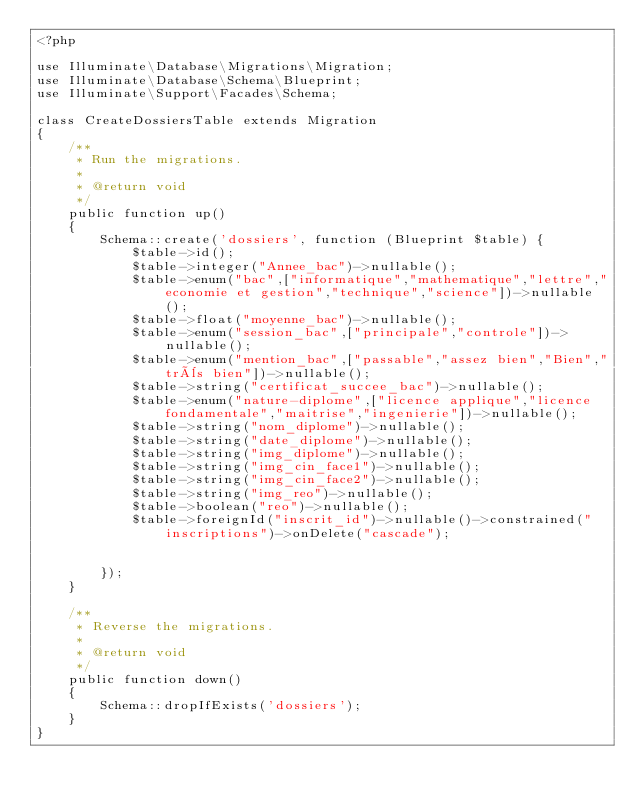<code> <loc_0><loc_0><loc_500><loc_500><_PHP_><?php

use Illuminate\Database\Migrations\Migration;
use Illuminate\Database\Schema\Blueprint;
use Illuminate\Support\Facades\Schema;

class CreateDossiersTable extends Migration
{
    /**
     * Run the migrations.
     *
     * @return void
     */
    public function up()
    {
        Schema::create('dossiers', function (Blueprint $table) {
            $table->id();
            $table->integer("Annee_bac")->nullable();
            $table->enum("bac",["informatique","mathematique","lettre","economie et gestion","technique","science"])->nullable();
            $table->float("moyenne_bac")->nullable();
            $table->enum("session_bac",["principale","controle"])->nullable();
            $table->enum("mention_bac",["passable","assez bien","Bien","très bien"])->nullable();
            $table->string("certificat_succee_bac")->nullable();
            $table->enum("nature-diplome",["licence applique","licence fondamentale","maitrise","ingenierie"])->nullable();
            $table->string("nom_diplome")->nullable();
            $table->string("date_diplome")->nullable();
            $table->string("img_diplome")->nullable();
            $table->string("img_cin_face1")->nullable();
            $table->string("img_cin_face2")->nullable();
            $table->string("img_reo")->nullable();
            $table->boolean("reo")->nullable();
            $table->foreignId("inscrit_id")->nullable()->constrained("inscriptions")->onDelete("cascade");


        });
    }

    /**
     * Reverse the migrations.
     *
     * @return void
     */
    public function down()
    {
        Schema::dropIfExists('dossiers');
    }
}
</code> 